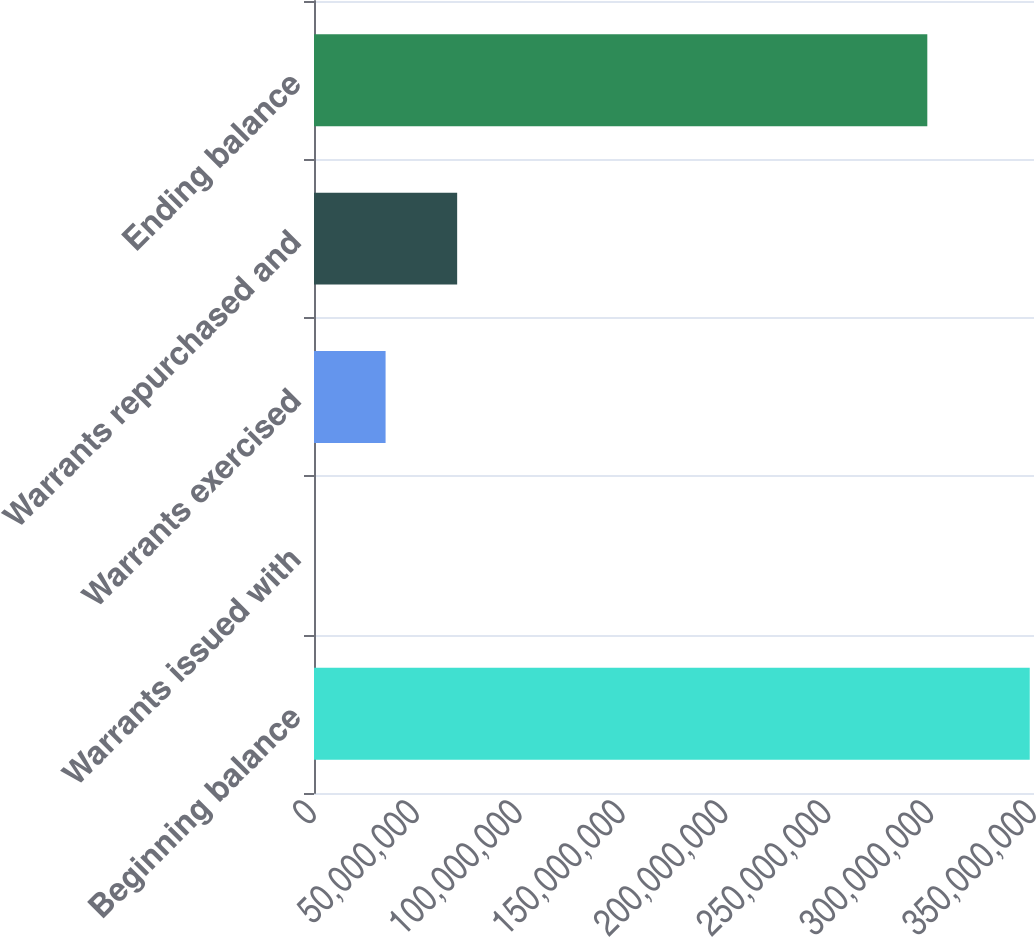Convert chart. <chart><loc_0><loc_0><loc_500><loc_500><bar_chart><fcel>Beginning balance<fcel>Warrants issued with<fcel>Warrants exercised<fcel>Warrants repurchased and<fcel>Ending balance<nl><fcel>3.47933e+08<fcel>4315<fcel>3.47972e+07<fcel>6.95901e+07<fcel>2.98136e+08<nl></chart> 